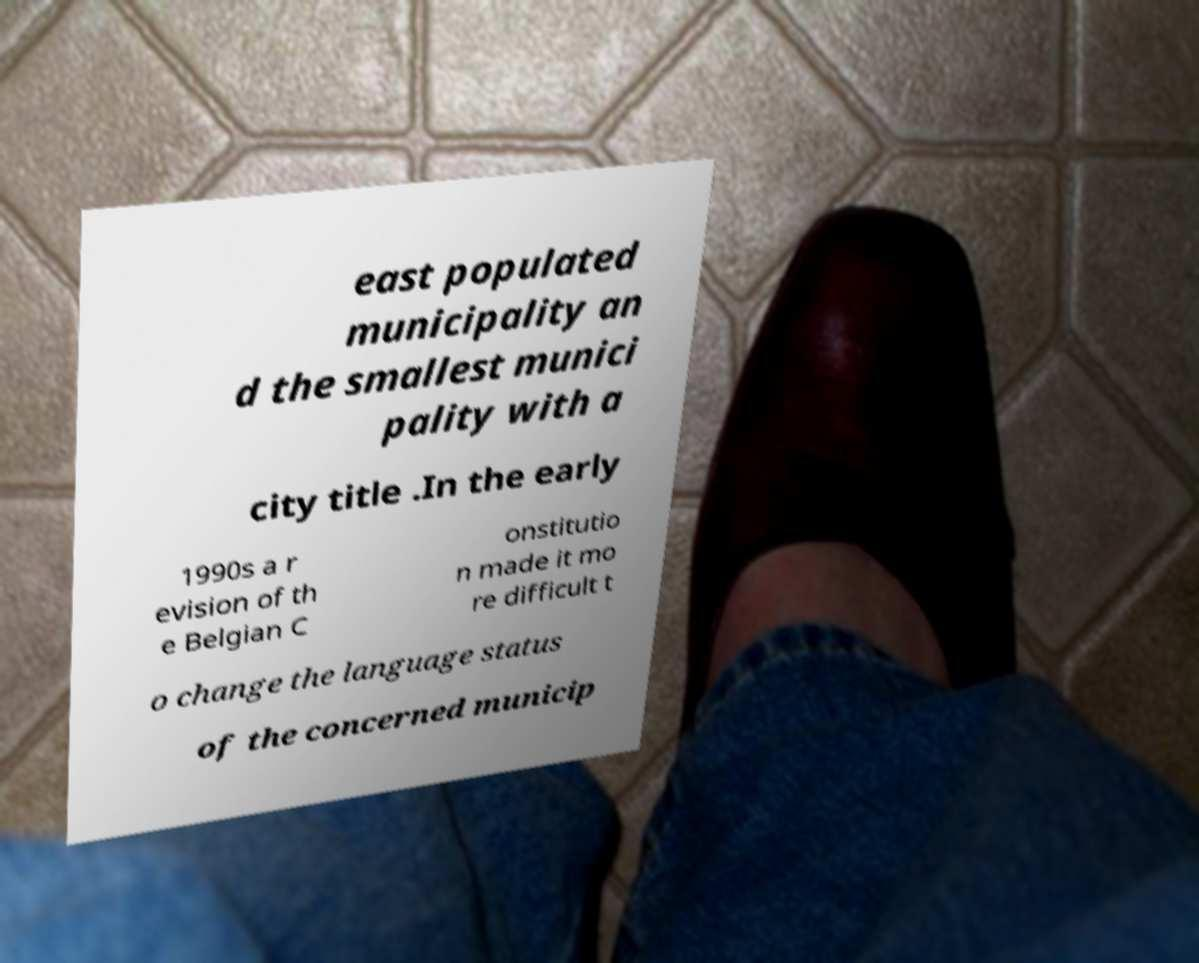Please read and relay the text visible in this image. What does it say? east populated municipality an d the smallest munici pality with a city title .In the early 1990s a r evision of th e Belgian C onstitutio n made it mo re difficult t o change the language status of the concerned municip 